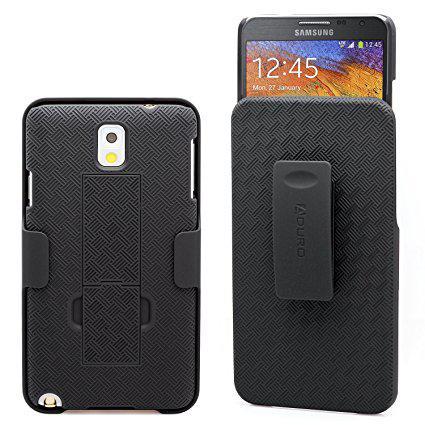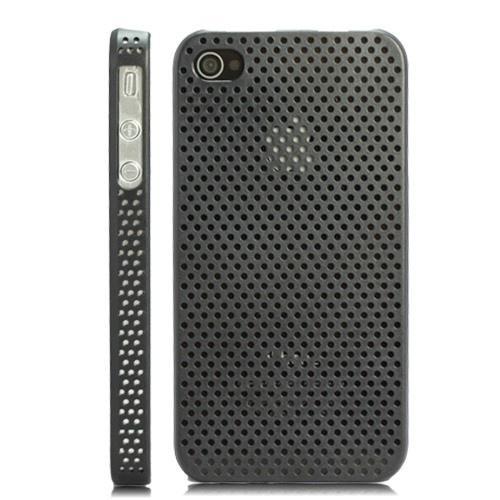The first image is the image on the left, the second image is the image on the right. Analyze the images presented: Is the assertion "The left and right image contains the same number of phones with at least one backside of the phone showing." valid? Answer yes or no. Yes. The first image is the image on the left, the second image is the image on the right. Analyze the images presented: Is the assertion "Each image contains exactly two phones, and the phones depicted are displayed upright but not overlapping." valid? Answer yes or no. Yes. 